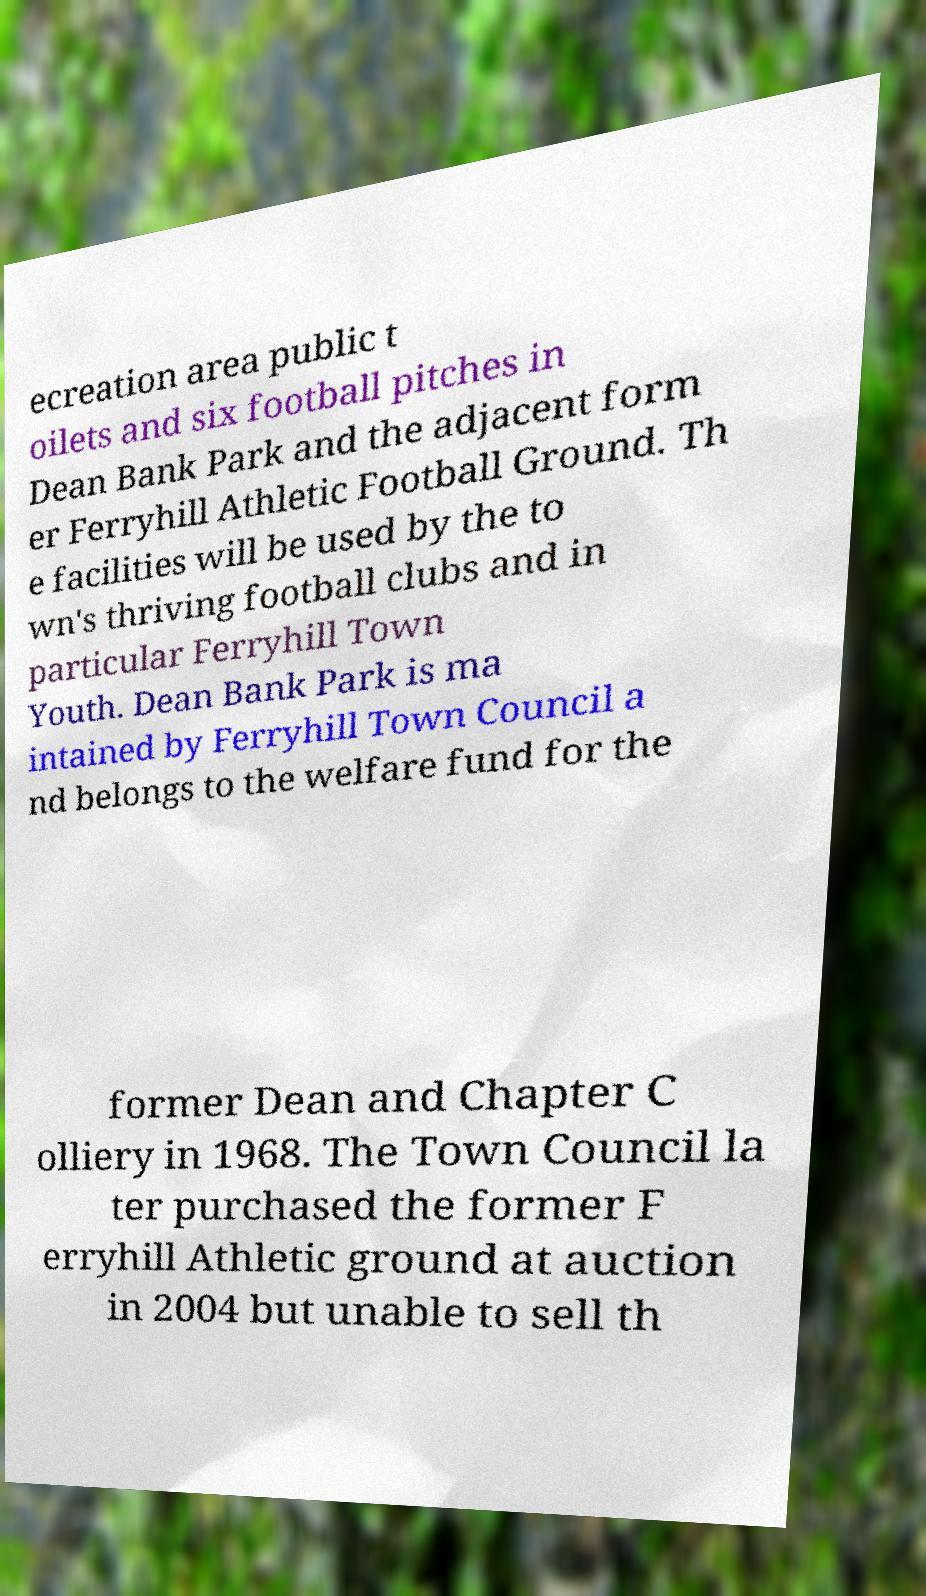Can you read and provide the text displayed in the image?This photo seems to have some interesting text. Can you extract and type it out for me? ecreation area public t oilets and six football pitches in Dean Bank Park and the adjacent form er Ferryhill Athletic Football Ground. Th e facilities will be used by the to wn's thriving football clubs and in particular Ferryhill Town Youth. Dean Bank Park is ma intained by Ferryhill Town Council a nd belongs to the welfare fund for the former Dean and Chapter C olliery in 1968. The Town Council la ter purchased the former F erryhill Athletic ground at auction in 2004 but unable to sell th 